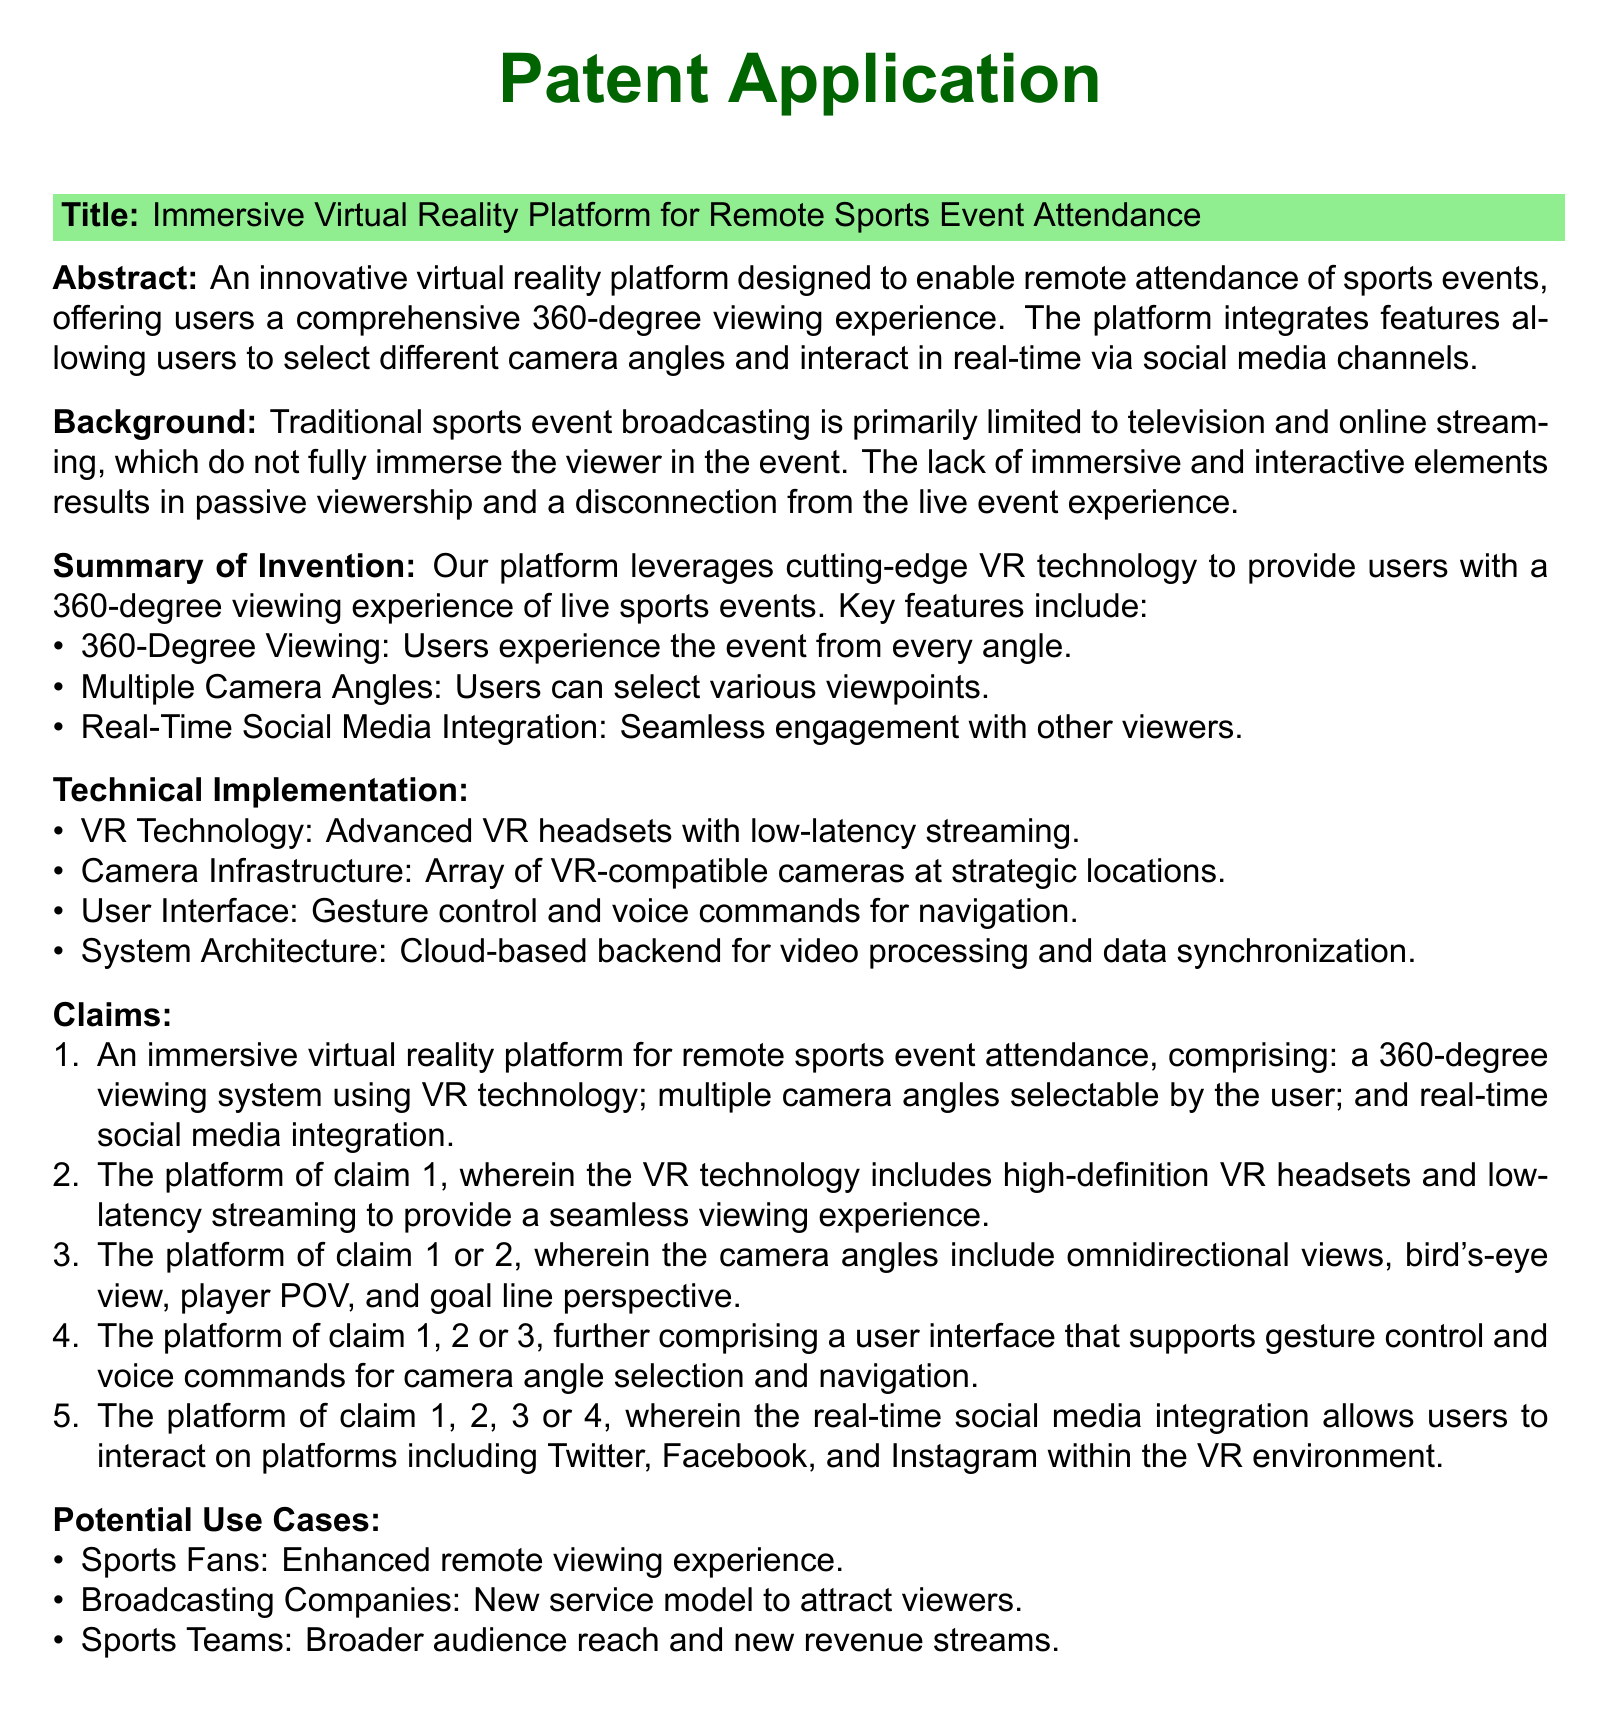What is the title of the patent application? The title of the patent application is presented in the document's header section.
Answer: Immersive Virtual Reality Platform for Remote Sports Event Attendance What are the primary viewing features mentioned? The primary viewing features are outlined in the summary of the invention.
Answer: 360-Degree Viewing, Multiple Camera Angles, Real-Time Social Media Integration What technology does the platform utilize for viewing? The technology used is described in the technical implementation section.
Answer: VR technology What type of user interface does the platform support? The user interface features are listed in the technical implementation section.
Answer: Gesture control and voice commands What potential use case is mentioned for sports teams? The potential use cases for sports teams are summarized in the respective section.
Answer: Broader audience reach and new revenue streams How many claims are presented in the patent application? The number of claims is indicated by the listing in the claims section.
Answer: Five What type of cameras are included in the infrastructure? The type of cameras is detailed in the technical implementation section.
Answer: VR-compatible cameras Which social media platforms are integrated in the application? The social media platforms are specified in the claims section.
Answer: Twitter, Facebook, and Instagram 